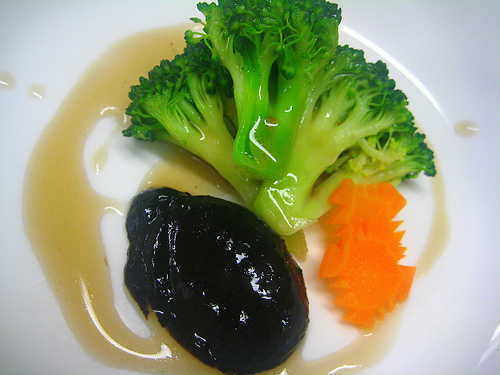Do you see either any cheese or soup there?
Answer the question using a single word or phrase. No What do you think is the color of the dish? White 